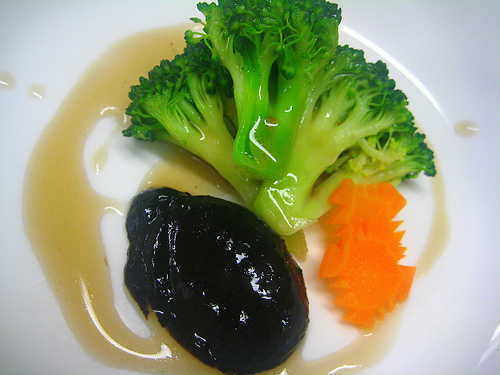Do you see either any cheese or soup there?
Answer the question using a single word or phrase. No What do you think is the color of the dish? White 